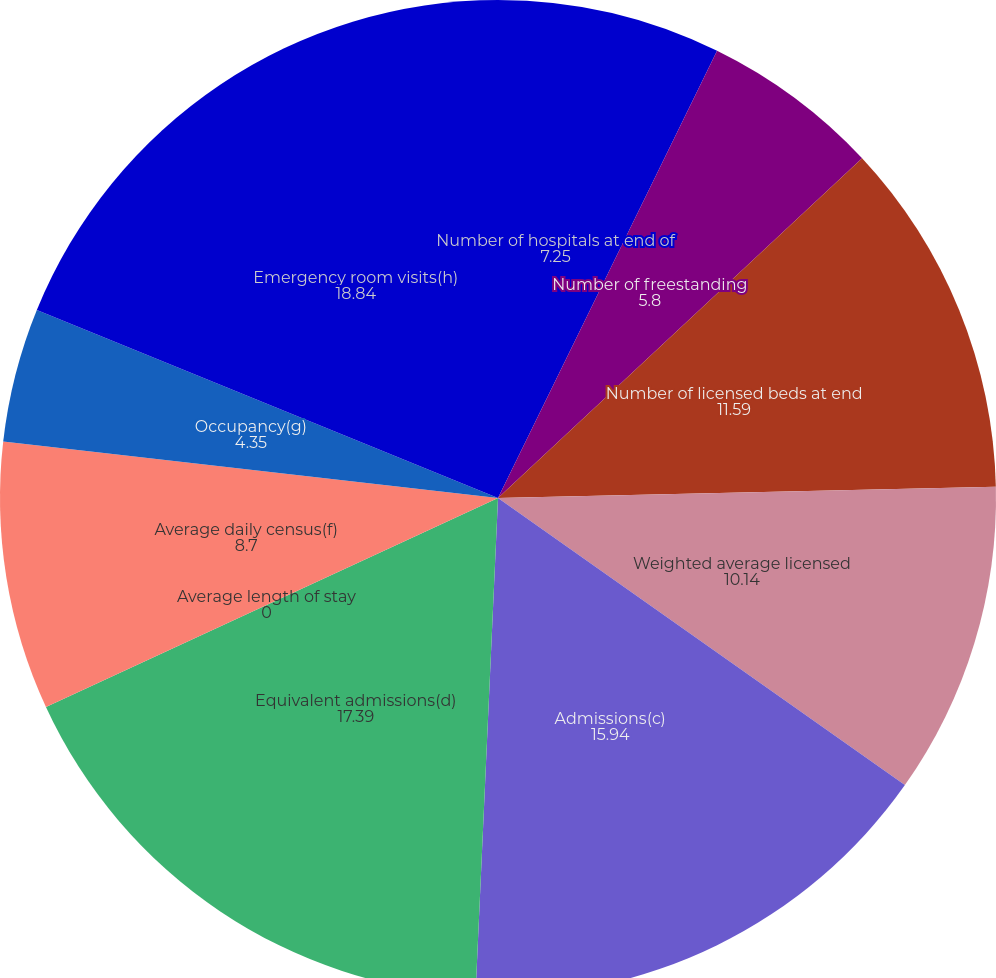<chart> <loc_0><loc_0><loc_500><loc_500><pie_chart><fcel>Number of hospitals at end of<fcel>Number of freestanding<fcel>Number of licensed beds at end<fcel>Weighted average licensed<fcel>Admissions(c)<fcel>Equivalent admissions(d)<fcel>Average length of stay<fcel>Average daily census(f)<fcel>Occupancy(g)<fcel>Emergency room visits(h)<nl><fcel>7.25%<fcel>5.8%<fcel>11.59%<fcel>10.14%<fcel>15.94%<fcel>17.39%<fcel>0.0%<fcel>8.7%<fcel>4.35%<fcel>18.84%<nl></chart> 